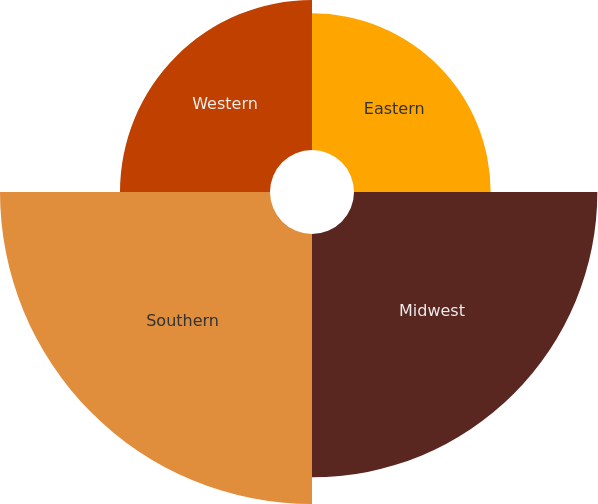Convert chart. <chart><loc_0><loc_0><loc_500><loc_500><pie_chart><fcel>Eastern<fcel>Midwest<fcel>Southern<fcel>Western<nl><fcel>17.08%<fcel>30.42%<fcel>33.75%<fcel>18.75%<nl></chart> 